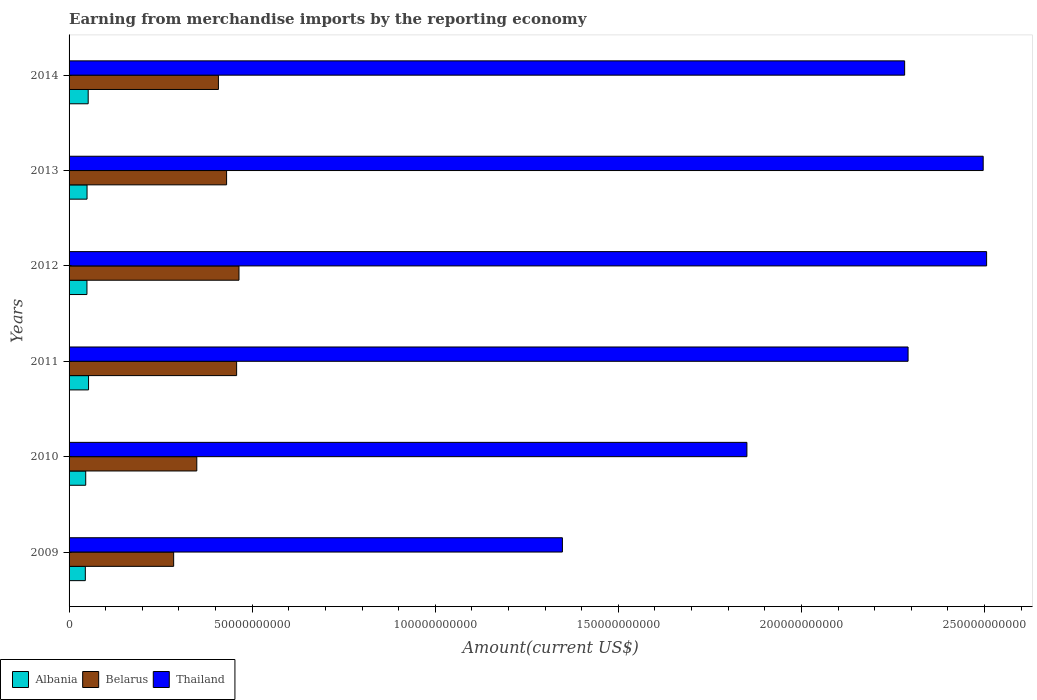How many different coloured bars are there?
Provide a short and direct response. 3. Are the number of bars per tick equal to the number of legend labels?
Your answer should be very brief. Yes. How many bars are there on the 5th tick from the bottom?
Keep it short and to the point. 3. What is the amount earned from merchandise imports in Thailand in 2010?
Provide a succinct answer. 1.85e+11. Across all years, what is the maximum amount earned from merchandise imports in Belarus?
Your answer should be very brief. 4.64e+1. Across all years, what is the minimum amount earned from merchandise imports in Belarus?
Provide a short and direct response. 2.86e+1. In which year was the amount earned from merchandise imports in Thailand minimum?
Your answer should be very brief. 2009. What is the total amount earned from merchandise imports in Thailand in the graph?
Make the answer very short. 1.28e+12. What is the difference between the amount earned from merchandise imports in Thailand in 2012 and that in 2013?
Provide a short and direct response. 9.36e+08. What is the difference between the amount earned from merchandise imports in Thailand in 2011 and the amount earned from merchandise imports in Albania in 2013?
Keep it short and to the point. 2.24e+11. What is the average amount earned from merchandise imports in Belarus per year?
Ensure brevity in your answer.  3.99e+1. In the year 2012, what is the difference between the amount earned from merchandise imports in Albania and amount earned from merchandise imports in Belarus?
Provide a succinct answer. -4.15e+1. In how many years, is the amount earned from merchandise imports in Belarus greater than 170000000000 US$?
Offer a very short reply. 0. What is the ratio of the amount earned from merchandise imports in Belarus in 2012 to that in 2014?
Offer a terse response. 1.14. What is the difference between the highest and the second highest amount earned from merchandise imports in Thailand?
Ensure brevity in your answer.  9.36e+08. What is the difference between the highest and the lowest amount earned from merchandise imports in Albania?
Keep it short and to the point. 8.78e+08. In how many years, is the amount earned from merchandise imports in Albania greater than the average amount earned from merchandise imports in Albania taken over all years?
Keep it short and to the point. 3. What does the 1st bar from the top in 2009 represents?
Provide a succinct answer. Thailand. What does the 3rd bar from the bottom in 2010 represents?
Your response must be concise. Thailand. Is it the case that in every year, the sum of the amount earned from merchandise imports in Thailand and amount earned from merchandise imports in Belarus is greater than the amount earned from merchandise imports in Albania?
Keep it short and to the point. Yes. Are all the bars in the graph horizontal?
Ensure brevity in your answer.  Yes. How many years are there in the graph?
Give a very brief answer. 6. Does the graph contain grids?
Offer a very short reply. No. Where does the legend appear in the graph?
Offer a terse response. Bottom left. How many legend labels are there?
Make the answer very short. 3. What is the title of the graph?
Offer a terse response. Earning from merchandise imports by the reporting economy. Does "Curacao" appear as one of the legend labels in the graph?
Offer a terse response. No. What is the label or title of the X-axis?
Provide a short and direct response. Amount(current US$). What is the label or title of the Y-axis?
Your answer should be compact. Years. What is the Amount(current US$) in Albania in 2009?
Give a very brief answer. 4.44e+09. What is the Amount(current US$) of Belarus in 2009?
Offer a terse response. 2.86e+1. What is the Amount(current US$) of Thailand in 2009?
Provide a short and direct response. 1.35e+11. What is the Amount(current US$) of Albania in 2010?
Provide a succinct answer. 4.55e+09. What is the Amount(current US$) of Belarus in 2010?
Your answer should be very brief. 3.49e+1. What is the Amount(current US$) of Thailand in 2010?
Ensure brevity in your answer.  1.85e+11. What is the Amount(current US$) of Albania in 2011?
Your response must be concise. 5.32e+09. What is the Amount(current US$) in Belarus in 2011?
Your answer should be compact. 4.58e+1. What is the Amount(current US$) in Thailand in 2011?
Offer a very short reply. 2.29e+11. What is the Amount(current US$) of Albania in 2012?
Give a very brief answer. 4.88e+09. What is the Amount(current US$) in Belarus in 2012?
Keep it short and to the point. 4.64e+1. What is the Amount(current US$) of Thailand in 2012?
Keep it short and to the point. 2.51e+11. What is the Amount(current US$) of Albania in 2013?
Your answer should be compact. 4.91e+09. What is the Amount(current US$) of Belarus in 2013?
Offer a very short reply. 4.30e+1. What is the Amount(current US$) of Thailand in 2013?
Offer a very short reply. 2.50e+11. What is the Amount(current US$) in Albania in 2014?
Keep it short and to the point. 5.22e+09. What is the Amount(current US$) of Belarus in 2014?
Your response must be concise. 4.08e+1. What is the Amount(current US$) of Thailand in 2014?
Keep it short and to the point. 2.28e+11. Across all years, what is the maximum Amount(current US$) of Albania?
Offer a very short reply. 5.32e+09. Across all years, what is the maximum Amount(current US$) in Belarus?
Keep it short and to the point. 4.64e+1. Across all years, what is the maximum Amount(current US$) of Thailand?
Offer a terse response. 2.51e+11. Across all years, what is the minimum Amount(current US$) of Albania?
Keep it short and to the point. 4.44e+09. Across all years, what is the minimum Amount(current US$) of Belarus?
Offer a terse response. 2.86e+1. Across all years, what is the minimum Amount(current US$) of Thailand?
Your response must be concise. 1.35e+11. What is the total Amount(current US$) of Albania in the graph?
Give a very brief answer. 2.93e+1. What is the total Amount(current US$) of Belarus in the graph?
Offer a terse response. 2.39e+11. What is the total Amount(current US$) in Thailand in the graph?
Provide a short and direct response. 1.28e+12. What is the difference between the Amount(current US$) of Albania in 2009 and that in 2010?
Give a very brief answer. -1.07e+08. What is the difference between the Amount(current US$) of Belarus in 2009 and that in 2010?
Give a very brief answer. -6.32e+09. What is the difference between the Amount(current US$) of Thailand in 2009 and that in 2010?
Offer a terse response. -5.04e+1. What is the difference between the Amount(current US$) in Albania in 2009 and that in 2011?
Your answer should be very brief. -8.78e+08. What is the difference between the Amount(current US$) of Belarus in 2009 and that in 2011?
Offer a very short reply. -1.72e+1. What is the difference between the Amount(current US$) of Thailand in 2009 and that in 2011?
Provide a succinct answer. -9.44e+1. What is the difference between the Amount(current US$) in Albania in 2009 and that in 2012?
Your response must be concise. -4.45e+08. What is the difference between the Amount(current US$) of Belarus in 2009 and that in 2012?
Give a very brief answer. -1.78e+1. What is the difference between the Amount(current US$) in Thailand in 2009 and that in 2012?
Offer a very short reply. -1.16e+11. What is the difference between the Amount(current US$) in Albania in 2009 and that in 2013?
Your response must be concise. -4.68e+08. What is the difference between the Amount(current US$) in Belarus in 2009 and that in 2013?
Offer a very short reply. -1.45e+1. What is the difference between the Amount(current US$) of Thailand in 2009 and that in 2013?
Provide a short and direct response. -1.15e+11. What is the difference between the Amount(current US$) in Albania in 2009 and that in 2014?
Provide a succinct answer. -7.82e+08. What is the difference between the Amount(current US$) of Belarus in 2009 and that in 2014?
Give a very brief answer. -1.22e+1. What is the difference between the Amount(current US$) of Thailand in 2009 and that in 2014?
Keep it short and to the point. -9.35e+1. What is the difference between the Amount(current US$) of Albania in 2010 and that in 2011?
Offer a terse response. -7.72e+08. What is the difference between the Amount(current US$) of Belarus in 2010 and that in 2011?
Give a very brief answer. -1.09e+1. What is the difference between the Amount(current US$) in Thailand in 2010 and that in 2011?
Offer a terse response. -4.40e+1. What is the difference between the Amount(current US$) in Albania in 2010 and that in 2012?
Your response must be concise. -3.38e+08. What is the difference between the Amount(current US$) of Belarus in 2010 and that in 2012?
Ensure brevity in your answer.  -1.15e+1. What is the difference between the Amount(current US$) in Thailand in 2010 and that in 2012?
Give a very brief answer. -6.55e+1. What is the difference between the Amount(current US$) of Albania in 2010 and that in 2013?
Provide a short and direct response. -3.61e+08. What is the difference between the Amount(current US$) in Belarus in 2010 and that in 2013?
Your response must be concise. -8.14e+09. What is the difference between the Amount(current US$) of Thailand in 2010 and that in 2013?
Keep it short and to the point. -6.45e+1. What is the difference between the Amount(current US$) in Albania in 2010 and that in 2014?
Provide a short and direct response. -6.76e+08. What is the difference between the Amount(current US$) in Belarus in 2010 and that in 2014?
Your answer should be compact. -5.90e+09. What is the difference between the Amount(current US$) in Thailand in 2010 and that in 2014?
Provide a succinct answer. -4.31e+1. What is the difference between the Amount(current US$) of Albania in 2011 and that in 2012?
Offer a terse response. 4.34e+08. What is the difference between the Amount(current US$) in Belarus in 2011 and that in 2012?
Offer a terse response. -6.45e+08. What is the difference between the Amount(current US$) in Thailand in 2011 and that in 2012?
Offer a very short reply. -2.15e+1. What is the difference between the Amount(current US$) of Albania in 2011 and that in 2013?
Your answer should be very brief. 4.11e+08. What is the difference between the Amount(current US$) in Belarus in 2011 and that in 2013?
Your response must be concise. 2.74e+09. What is the difference between the Amount(current US$) of Thailand in 2011 and that in 2013?
Give a very brief answer. -2.05e+1. What is the difference between the Amount(current US$) of Albania in 2011 and that in 2014?
Offer a very short reply. 9.61e+07. What is the difference between the Amount(current US$) of Belarus in 2011 and that in 2014?
Offer a terse response. 4.97e+09. What is the difference between the Amount(current US$) of Thailand in 2011 and that in 2014?
Keep it short and to the point. 9.36e+08. What is the difference between the Amount(current US$) of Albania in 2012 and that in 2013?
Your response must be concise. -2.31e+07. What is the difference between the Amount(current US$) in Belarus in 2012 and that in 2013?
Provide a short and direct response. 3.38e+09. What is the difference between the Amount(current US$) of Thailand in 2012 and that in 2013?
Provide a succinct answer. 9.36e+08. What is the difference between the Amount(current US$) in Albania in 2012 and that in 2014?
Your answer should be compact. -3.38e+08. What is the difference between the Amount(current US$) of Belarus in 2012 and that in 2014?
Your response must be concise. 5.62e+09. What is the difference between the Amount(current US$) in Thailand in 2012 and that in 2014?
Provide a succinct answer. 2.24e+1. What is the difference between the Amount(current US$) in Albania in 2013 and that in 2014?
Offer a very short reply. -3.14e+08. What is the difference between the Amount(current US$) in Belarus in 2013 and that in 2014?
Offer a terse response. 2.23e+09. What is the difference between the Amount(current US$) in Thailand in 2013 and that in 2014?
Your answer should be compact. 2.15e+1. What is the difference between the Amount(current US$) of Albania in 2009 and the Amount(current US$) of Belarus in 2010?
Provide a short and direct response. -3.04e+1. What is the difference between the Amount(current US$) of Albania in 2009 and the Amount(current US$) of Thailand in 2010?
Offer a very short reply. -1.81e+11. What is the difference between the Amount(current US$) of Belarus in 2009 and the Amount(current US$) of Thailand in 2010?
Your answer should be very brief. -1.57e+11. What is the difference between the Amount(current US$) in Albania in 2009 and the Amount(current US$) in Belarus in 2011?
Provide a short and direct response. -4.13e+1. What is the difference between the Amount(current US$) of Albania in 2009 and the Amount(current US$) of Thailand in 2011?
Offer a terse response. -2.25e+11. What is the difference between the Amount(current US$) in Belarus in 2009 and the Amount(current US$) in Thailand in 2011?
Give a very brief answer. -2.01e+11. What is the difference between the Amount(current US$) of Albania in 2009 and the Amount(current US$) of Belarus in 2012?
Offer a very short reply. -4.20e+1. What is the difference between the Amount(current US$) of Albania in 2009 and the Amount(current US$) of Thailand in 2012?
Offer a very short reply. -2.46e+11. What is the difference between the Amount(current US$) of Belarus in 2009 and the Amount(current US$) of Thailand in 2012?
Provide a short and direct response. -2.22e+11. What is the difference between the Amount(current US$) of Albania in 2009 and the Amount(current US$) of Belarus in 2013?
Your answer should be very brief. -3.86e+1. What is the difference between the Amount(current US$) in Albania in 2009 and the Amount(current US$) in Thailand in 2013?
Give a very brief answer. -2.45e+11. What is the difference between the Amount(current US$) in Belarus in 2009 and the Amount(current US$) in Thailand in 2013?
Make the answer very short. -2.21e+11. What is the difference between the Amount(current US$) of Albania in 2009 and the Amount(current US$) of Belarus in 2014?
Provide a succinct answer. -3.63e+1. What is the difference between the Amount(current US$) of Albania in 2009 and the Amount(current US$) of Thailand in 2014?
Make the answer very short. -2.24e+11. What is the difference between the Amount(current US$) in Belarus in 2009 and the Amount(current US$) in Thailand in 2014?
Keep it short and to the point. -2.00e+11. What is the difference between the Amount(current US$) in Albania in 2010 and the Amount(current US$) in Belarus in 2011?
Your answer should be very brief. -4.12e+1. What is the difference between the Amount(current US$) of Albania in 2010 and the Amount(current US$) of Thailand in 2011?
Keep it short and to the point. -2.25e+11. What is the difference between the Amount(current US$) in Belarus in 2010 and the Amount(current US$) in Thailand in 2011?
Your response must be concise. -1.94e+11. What is the difference between the Amount(current US$) of Albania in 2010 and the Amount(current US$) of Belarus in 2012?
Your answer should be very brief. -4.19e+1. What is the difference between the Amount(current US$) in Albania in 2010 and the Amount(current US$) in Thailand in 2012?
Your answer should be compact. -2.46e+11. What is the difference between the Amount(current US$) of Belarus in 2010 and the Amount(current US$) of Thailand in 2012?
Your answer should be compact. -2.16e+11. What is the difference between the Amount(current US$) in Albania in 2010 and the Amount(current US$) in Belarus in 2013?
Your answer should be very brief. -3.85e+1. What is the difference between the Amount(current US$) in Albania in 2010 and the Amount(current US$) in Thailand in 2013?
Your response must be concise. -2.45e+11. What is the difference between the Amount(current US$) of Belarus in 2010 and the Amount(current US$) of Thailand in 2013?
Offer a terse response. -2.15e+11. What is the difference between the Amount(current US$) in Albania in 2010 and the Amount(current US$) in Belarus in 2014?
Your response must be concise. -3.62e+1. What is the difference between the Amount(current US$) in Albania in 2010 and the Amount(current US$) in Thailand in 2014?
Keep it short and to the point. -2.24e+11. What is the difference between the Amount(current US$) in Belarus in 2010 and the Amount(current US$) in Thailand in 2014?
Make the answer very short. -1.93e+11. What is the difference between the Amount(current US$) in Albania in 2011 and the Amount(current US$) in Belarus in 2012?
Ensure brevity in your answer.  -4.11e+1. What is the difference between the Amount(current US$) in Albania in 2011 and the Amount(current US$) in Thailand in 2012?
Provide a succinct answer. -2.45e+11. What is the difference between the Amount(current US$) in Belarus in 2011 and the Amount(current US$) in Thailand in 2012?
Your response must be concise. -2.05e+11. What is the difference between the Amount(current US$) of Albania in 2011 and the Amount(current US$) of Belarus in 2013?
Keep it short and to the point. -3.77e+1. What is the difference between the Amount(current US$) of Albania in 2011 and the Amount(current US$) of Thailand in 2013?
Your answer should be very brief. -2.44e+11. What is the difference between the Amount(current US$) of Belarus in 2011 and the Amount(current US$) of Thailand in 2013?
Give a very brief answer. -2.04e+11. What is the difference between the Amount(current US$) of Albania in 2011 and the Amount(current US$) of Belarus in 2014?
Ensure brevity in your answer.  -3.55e+1. What is the difference between the Amount(current US$) in Albania in 2011 and the Amount(current US$) in Thailand in 2014?
Offer a very short reply. -2.23e+11. What is the difference between the Amount(current US$) of Belarus in 2011 and the Amount(current US$) of Thailand in 2014?
Make the answer very short. -1.82e+11. What is the difference between the Amount(current US$) in Albania in 2012 and the Amount(current US$) in Belarus in 2013?
Give a very brief answer. -3.81e+1. What is the difference between the Amount(current US$) in Albania in 2012 and the Amount(current US$) in Thailand in 2013?
Your answer should be compact. -2.45e+11. What is the difference between the Amount(current US$) in Belarus in 2012 and the Amount(current US$) in Thailand in 2013?
Provide a succinct answer. -2.03e+11. What is the difference between the Amount(current US$) of Albania in 2012 and the Amount(current US$) of Belarus in 2014?
Keep it short and to the point. -3.59e+1. What is the difference between the Amount(current US$) of Albania in 2012 and the Amount(current US$) of Thailand in 2014?
Offer a very short reply. -2.23e+11. What is the difference between the Amount(current US$) of Belarus in 2012 and the Amount(current US$) of Thailand in 2014?
Ensure brevity in your answer.  -1.82e+11. What is the difference between the Amount(current US$) in Albania in 2013 and the Amount(current US$) in Belarus in 2014?
Your answer should be compact. -3.59e+1. What is the difference between the Amount(current US$) of Albania in 2013 and the Amount(current US$) of Thailand in 2014?
Your answer should be compact. -2.23e+11. What is the difference between the Amount(current US$) of Belarus in 2013 and the Amount(current US$) of Thailand in 2014?
Give a very brief answer. -1.85e+11. What is the average Amount(current US$) of Albania per year?
Your response must be concise. 4.89e+09. What is the average Amount(current US$) in Belarus per year?
Your answer should be very brief. 3.99e+1. What is the average Amount(current US$) of Thailand per year?
Your answer should be compact. 2.13e+11. In the year 2009, what is the difference between the Amount(current US$) in Albania and Amount(current US$) in Belarus?
Make the answer very short. -2.41e+1. In the year 2009, what is the difference between the Amount(current US$) of Albania and Amount(current US$) of Thailand?
Offer a terse response. -1.30e+11. In the year 2009, what is the difference between the Amount(current US$) in Belarus and Amount(current US$) in Thailand?
Keep it short and to the point. -1.06e+11. In the year 2010, what is the difference between the Amount(current US$) in Albania and Amount(current US$) in Belarus?
Make the answer very short. -3.03e+1. In the year 2010, what is the difference between the Amount(current US$) of Albania and Amount(current US$) of Thailand?
Provide a succinct answer. -1.81e+11. In the year 2010, what is the difference between the Amount(current US$) of Belarus and Amount(current US$) of Thailand?
Offer a terse response. -1.50e+11. In the year 2011, what is the difference between the Amount(current US$) of Albania and Amount(current US$) of Belarus?
Keep it short and to the point. -4.04e+1. In the year 2011, what is the difference between the Amount(current US$) of Albania and Amount(current US$) of Thailand?
Your answer should be very brief. -2.24e+11. In the year 2011, what is the difference between the Amount(current US$) of Belarus and Amount(current US$) of Thailand?
Provide a short and direct response. -1.83e+11. In the year 2012, what is the difference between the Amount(current US$) of Albania and Amount(current US$) of Belarus?
Provide a short and direct response. -4.15e+1. In the year 2012, what is the difference between the Amount(current US$) in Albania and Amount(current US$) in Thailand?
Keep it short and to the point. -2.46e+11. In the year 2012, what is the difference between the Amount(current US$) in Belarus and Amount(current US$) in Thailand?
Offer a very short reply. -2.04e+11. In the year 2013, what is the difference between the Amount(current US$) in Albania and Amount(current US$) in Belarus?
Your answer should be compact. -3.81e+1. In the year 2013, what is the difference between the Amount(current US$) in Albania and Amount(current US$) in Thailand?
Your response must be concise. -2.45e+11. In the year 2013, what is the difference between the Amount(current US$) in Belarus and Amount(current US$) in Thailand?
Offer a terse response. -2.07e+11. In the year 2014, what is the difference between the Amount(current US$) of Albania and Amount(current US$) of Belarus?
Give a very brief answer. -3.56e+1. In the year 2014, what is the difference between the Amount(current US$) of Albania and Amount(current US$) of Thailand?
Provide a succinct answer. -2.23e+11. In the year 2014, what is the difference between the Amount(current US$) in Belarus and Amount(current US$) in Thailand?
Make the answer very short. -1.87e+11. What is the ratio of the Amount(current US$) in Albania in 2009 to that in 2010?
Your answer should be compact. 0.98. What is the ratio of the Amount(current US$) in Belarus in 2009 to that in 2010?
Offer a terse response. 0.82. What is the ratio of the Amount(current US$) of Thailand in 2009 to that in 2010?
Offer a very short reply. 0.73. What is the ratio of the Amount(current US$) in Albania in 2009 to that in 2011?
Offer a terse response. 0.83. What is the ratio of the Amount(current US$) of Belarus in 2009 to that in 2011?
Provide a succinct answer. 0.62. What is the ratio of the Amount(current US$) in Thailand in 2009 to that in 2011?
Offer a very short reply. 0.59. What is the ratio of the Amount(current US$) in Albania in 2009 to that in 2012?
Make the answer very short. 0.91. What is the ratio of the Amount(current US$) in Belarus in 2009 to that in 2012?
Give a very brief answer. 0.62. What is the ratio of the Amount(current US$) of Thailand in 2009 to that in 2012?
Provide a succinct answer. 0.54. What is the ratio of the Amount(current US$) of Albania in 2009 to that in 2013?
Give a very brief answer. 0.9. What is the ratio of the Amount(current US$) in Belarus in 2009 to that in 2013?
Ensure brevity in your answer.  0.66. What is the ratio of the Amount(current US$) of Thailand in 2009 to that in 2013?
Provide a short and direct response. 0.54. What is the ratio of the Amount(current US$) of Albania in 2009 to that in 2014?
Keep it short and to the point. 0.85. What is the ratio of the Amount(current US$) of Belarus in 2009 to that in 2014?
Give a very brief answer. 0.7. What is the ratio of the Amount(current US$) in Thailand in 2009 to that in 2014?
Give a very brief answer. 0.59. What is the ratio of the Amount(current US$) in Albania in 2010 to that in 2011?
Give a very brief answer. 0.85. What is the ratio of the Amount(current US$) in Belarus in 2010 to that in 2011?
Make the answer very short. 0.76. What is the ratio of the Amount(current US$) in Thailand in 2010 to that in 2011?
Make the answer very short. 0.81. What is the ratio of the Amount(current US$) of Albania in 2010 to that in 2012?
Offer a very short reply. 0.93. What is the ratio of the Amount(current US$) in Belarus in 2010 to that in 2012?
Offer a very short reply. 0.75. What is the ratio of the Amount(current US$) in Thailand in 2010 to that in 2012?
Keep it short and to the point. 0.74. What is the ratio of the Amount(current US$) in Albania in 2010 to that in 2013?
Your response must be concise. 0.93. What is the ratio of the Amount(current US$) in Belarus in 2010 to that in 2013?
Your answer should be compact. 0.81. What is the ratio of the Amount(current US$) of Thailand in 2010 to that in 2013?
Your response must be concise. 0.74. What is the ratio of the Amount(current US$) in Albania in 2010 to that in 2014?
Your response must be concise. 0.87. What is the ratio of the Amount(current US$) of Belarus in 2010 to that in 2014?
Ensure brevity in your answer.  0.86. What is the ratio of the Amount(current US$) of Thailand in 2010 to that in 2014?
Offer a terse response. 0.81. What is the ratio of the Amount(current US$) in Albania in 2011 to that in 2012?
Offer a terse response. 1.09. What is the ratio of the Amount(current US$) of Belarus in 2011 to that in 2012?
Offer a very short reply. 0.99. What is the ratio of the Amount(current US$) of Thailand in 2011 to that in 2012?
Keep it short and to the point. 0.91. What is the ratio of the Amount(current US$) in Albania in 2011 to that in 2013?
Provide a succinct answer. 1.08. What is the ratio of the Amount(current US$) of Belarus in 2011 to that in 2013?
Ensure brevity in your answer.  1.06. What is the ratio of the Amount(current US$) in Thailand in 2011 to that in 2013?
Offer a very short reply. 0.92. What is the ratio of the Amount(current US$) in Albania in 2011 to that in 2014?
Provide a short and direct response. 1.02. What is the ratio of the Amount(current US$) in Belarus in 2011 to that in 2014?
Give a very brief answer. 1.12. What is the ratio of the Amount(current US$) in Belarus in 2012 to that in 2013?
Provide a succinct answer. 1.08. What is the ratio of the Amount(current US$) of Thailand in 2012 to that in 2013?
Your answer should be compact. 1. What is the ratio of the Amount(current US$) in Albania in 2012 to that in 2014?
Provide a short and direct response. 0.94. What is the ratio of the Amount(current US$) of Belarus in 2012 to that in 2014?
Keep it short and to the point. 1.14. What is the ratio of the Amount(current US$) in Thailand in 2012 to that in 2014?
Your response must be concise. 1.1. What is the ratio of the Amount(current US$) in Albania in 2013 to that in 2014?
Offer a very short reply. 0.94. What is the ratio of the Amount(current US$) of Belarus in 2013 to that in 2014?
Give a very brief answer. 1.05. What is the ratio of the Amount(current US$) of Thailand in 2013 to that in 2014?
Keep it short and to the point. 1.09. What is the difference between the highest and the second highest Amount(current US$) in Albania?
Your response must be concise. 9.61e+07. What is the difference between the highest and the second highest Amount(current US$) of Belarus?
Provide a succinct answer. 6.45e+08. What is the difference between the highest and the second highest Amount(current US$) in Thailand?
Offer a terse response. 9.36e+08. What is the difference between the highest and the lowest Amount(current US$) of Albania?
Offer a terse response. 8.78e+08. What is the difference between the highest and the lowest Amount(current US$) in Belarus?
Make the answer very short. 1.78e+1. What is the difference between the highest and the lowest Amount(current US$) of Thailand?
Offer a terse response. 1.16e+11. 